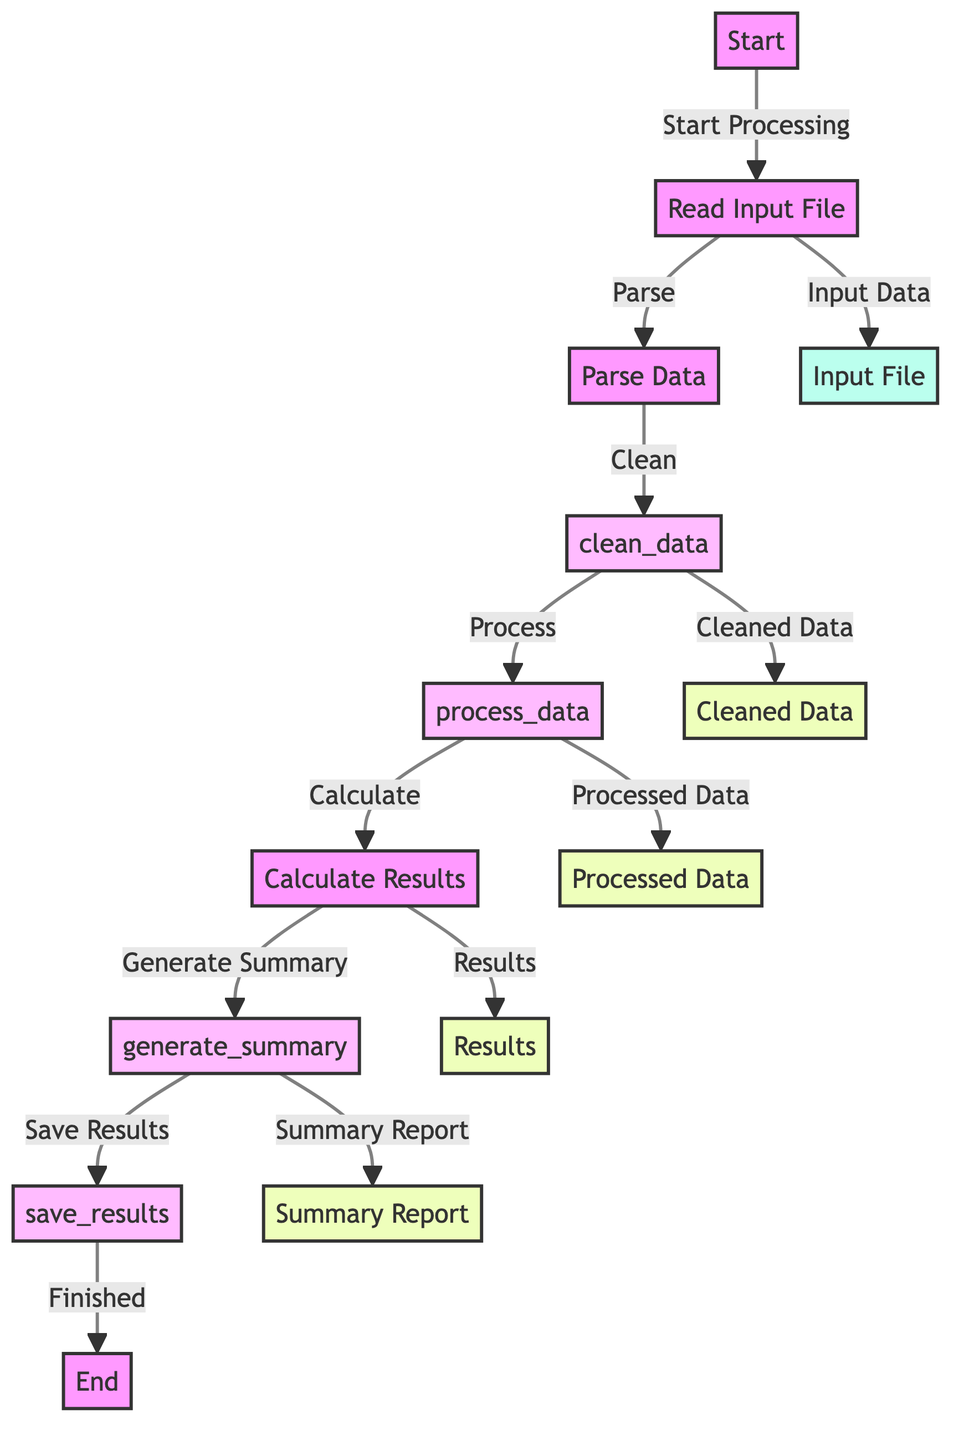What is the first step in the workflow? The first step in the workflow is labeled "Start," indicating the beginning of the process.
Answer: Start How many subroutines are defined in the diagram? The diagram includes four subroutines: clean_data, process_data, generate_summary, and save_results, totaling four.
Answer: Four What data is produced by the "clean_data" subroutine? The "clean_data" subroutine outputs "Cleaned Data," which is the processed result of the cleaning function applied to the parsed data.
Answer: Cleaned Data What is the last action taken before finishing the workflow? The last action before reaching the "End" is labeled as "Finished," indicating the completion of the process after results are saved.
Answer: Finished What node does the "Parse Data" step lead to? The "Parse Data" step leads to the "clean_data" subroutine, which signifies that the parsed data undergoes cleaning at that juncture.
Answer: clean_data What outputs are derived from the "Calculate Results" step? From the "Calculate Results" step, two outputs are generated: "Results" and the initiation of the "generate_summary" subroutine.
Answer: Results and generate_summary Which node is associated with the "Input Data"? The node associated with the "Input Data" is "Read Input File," indicating the step where the input data is first read into the workflow.
Answer: Read Input File How does the workflow conclude? The workflow concludes with the "End" node, indicating the termination of the process after all steps have been completed and results saved.
Answer: End Which nodes follow the "process_data" subroutine? After the "process_data" subroutine, the workflow moves to "Processed Data" next, followed by "Calculate Results."
Answer: Processed Data and Calculate Results 